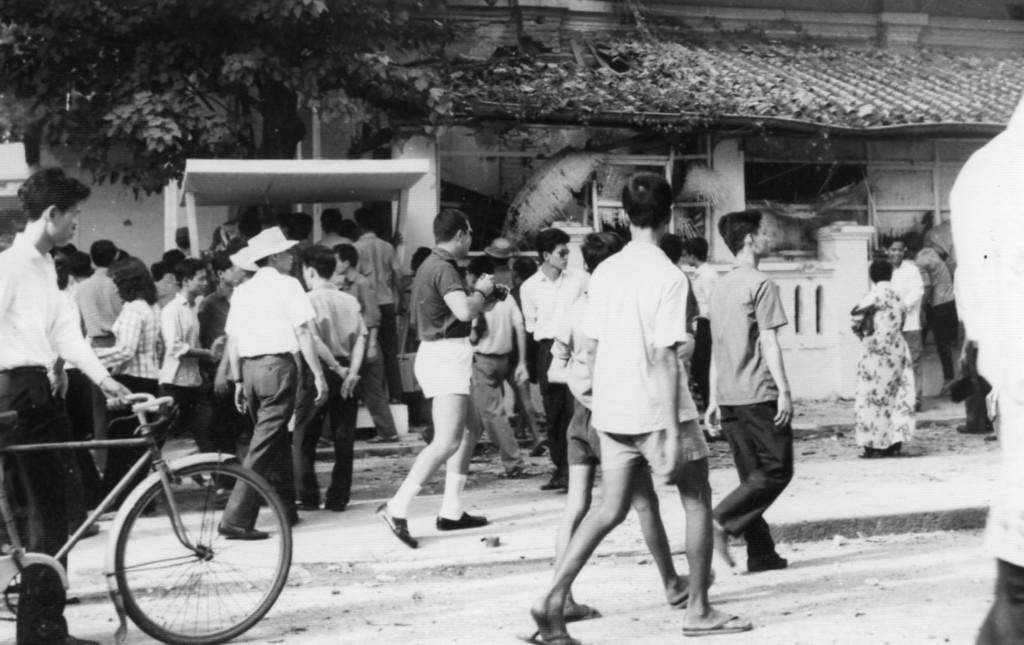What is the man at the left side of the image doing? The man is standing at the left side of the image and holding a bicycle. What are the people in the image doing? The people in the image are walking. What can be seen at the left side of the image besides the man? There is a green color tree at the left side of the image. How many planes are flying over the hill in the image? There is no hill or planes present in the image. What type of board is being used by the people walking in the image? There is no board present in the image; the people are simply walking. 